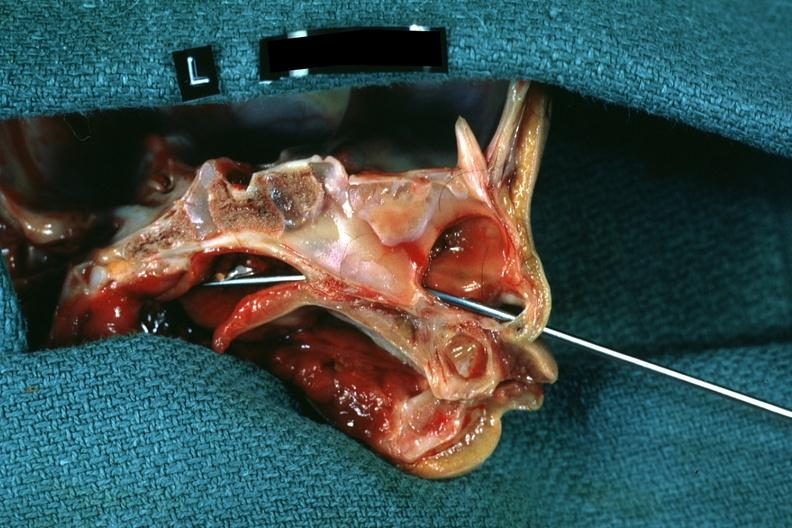s eye present?
Answer the question using a single word or phrase. No 